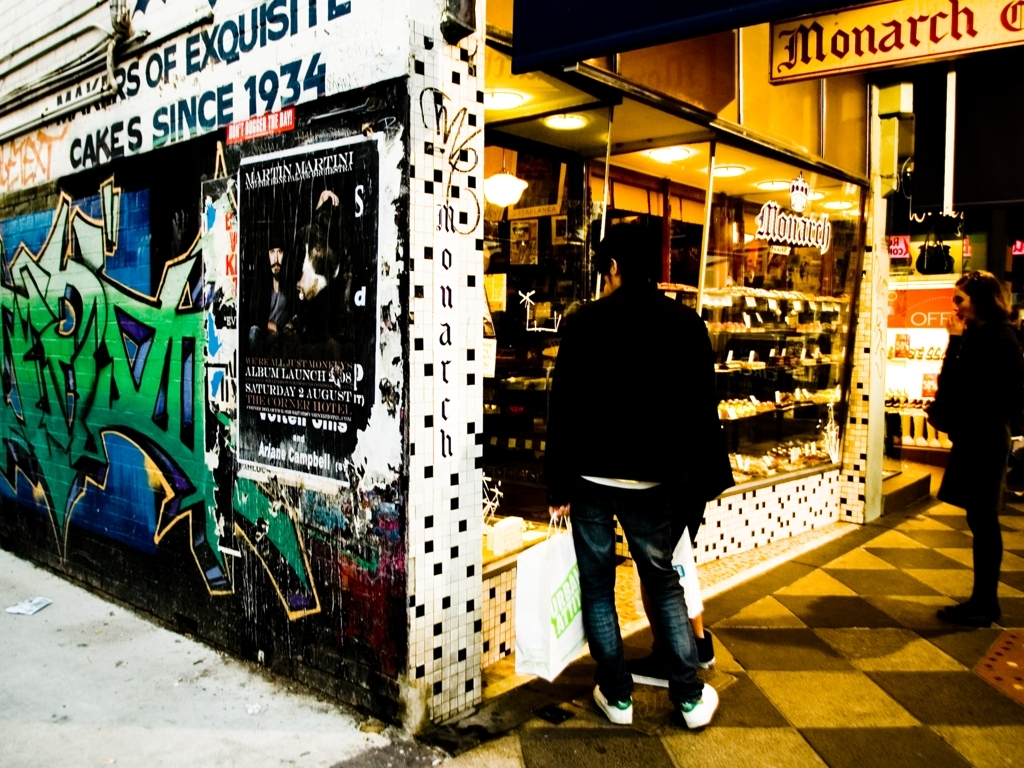What does the graffiti add to the ambiance of the street? The graffiti contributes to a contemporary, artistic ambiance, injecting color and vitality into the urban landscape. It represents a form of street-level expression, possibly enriching the area with a youthful, rebellious character that coexists with the more conventional businesses like the cake shop seen in the image. 